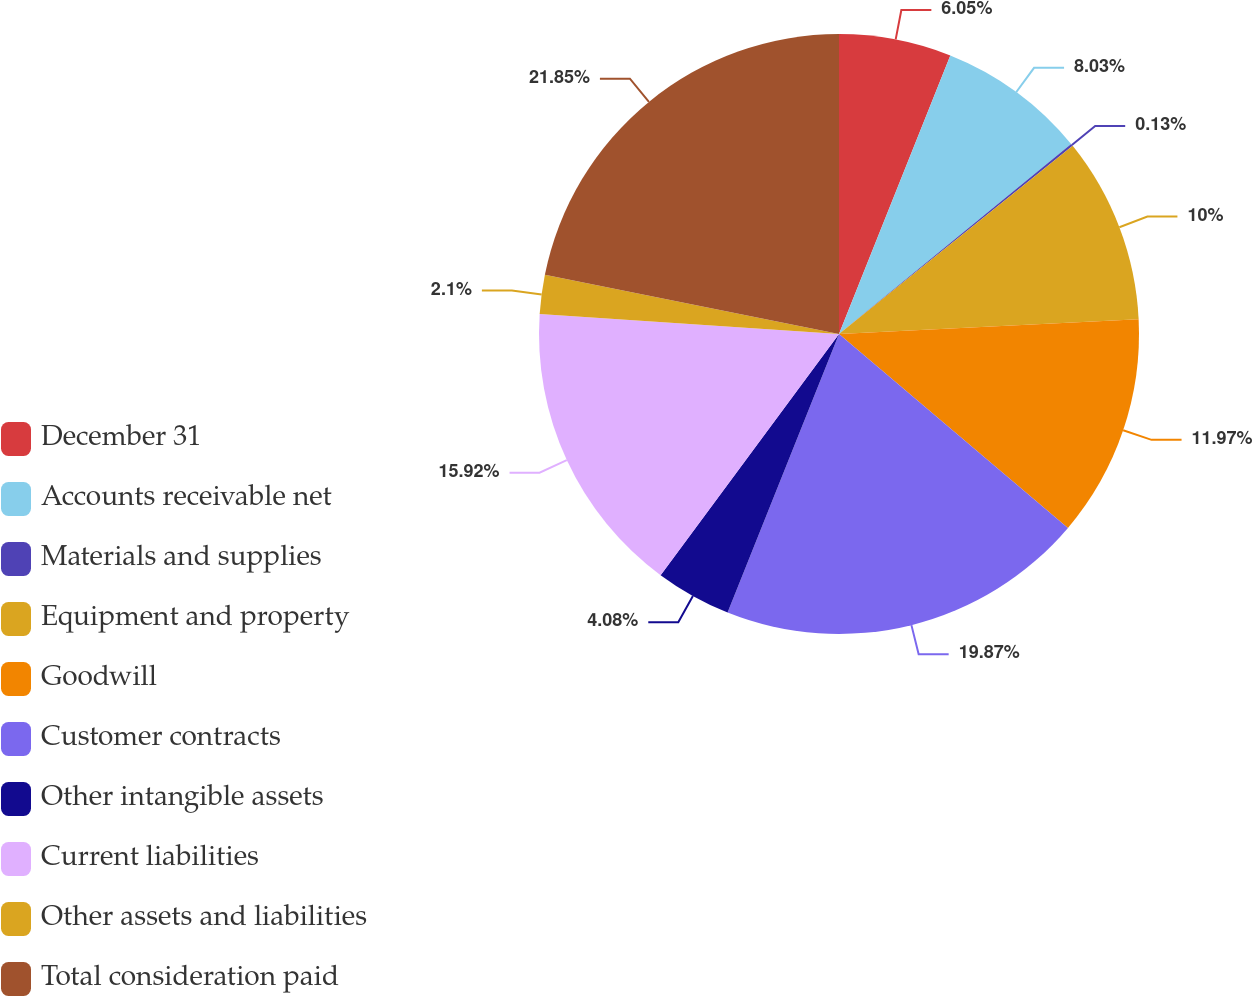Convert chart. <chart><loc_0><loc_0><loc_500><loc_500><pie_chart><fcel>December 31<fcel>Accounts receivable net<fcel>Materials and supplies<fcel>Equipment and property<fcel>Goodwill<fcel>Customer contracts<fcel>Other intangible assets<fcel>Current liabilities<fcel>Other assets and liabilities<fcel>Total consideration paid<nl><fcel>6.05%<fcel>8.03%<fcel>0.13%<fcel>10.0%<fcel>11.97%<fcel>19.87%<fcel>4.08%<fcel>15.92%<fcel>2.1%<fcel>21.84%<nl></chart> 